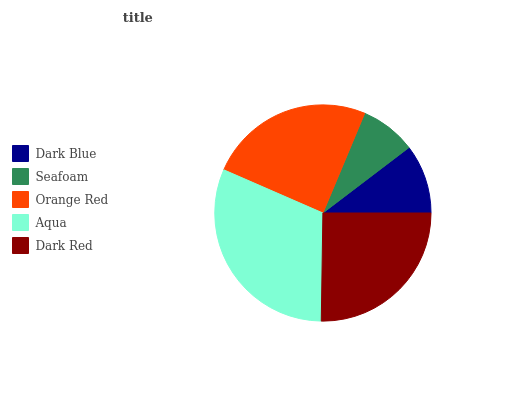Is Seafoam the minimum?
Answer yes or no. Yes. Is Aqua the maximum?
Answer yes or no. Yes. Is Orange Red the minimum?
Answer yes or no. No. Is Orange Red the maximum?
Answer yes or no. No. Is Orange Red greater than Seafoam?
Answer yes or no. Yes. Is Seafoam less than Orange Red?
Answer yes or no. Yes. Is Seafoam greater than Orange Red?
Answer yes or no. No. Is Orange Red less than Seafoam?
Answer yes or no. No. Is Orange Red the high median?
Answer yes or no. Yes. Is Orange Red the low median?
Answer yes or no. Yes. Is Dark Blue the high median?
Answer yes or no. No. Is Seafoam the low median?
Answer yes or no. No. 